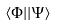Convert formula to latex. <formula><loc_0><loc_0><loc_500><loc_500>\langle \Phi | | \Psi \rangle</formula> 